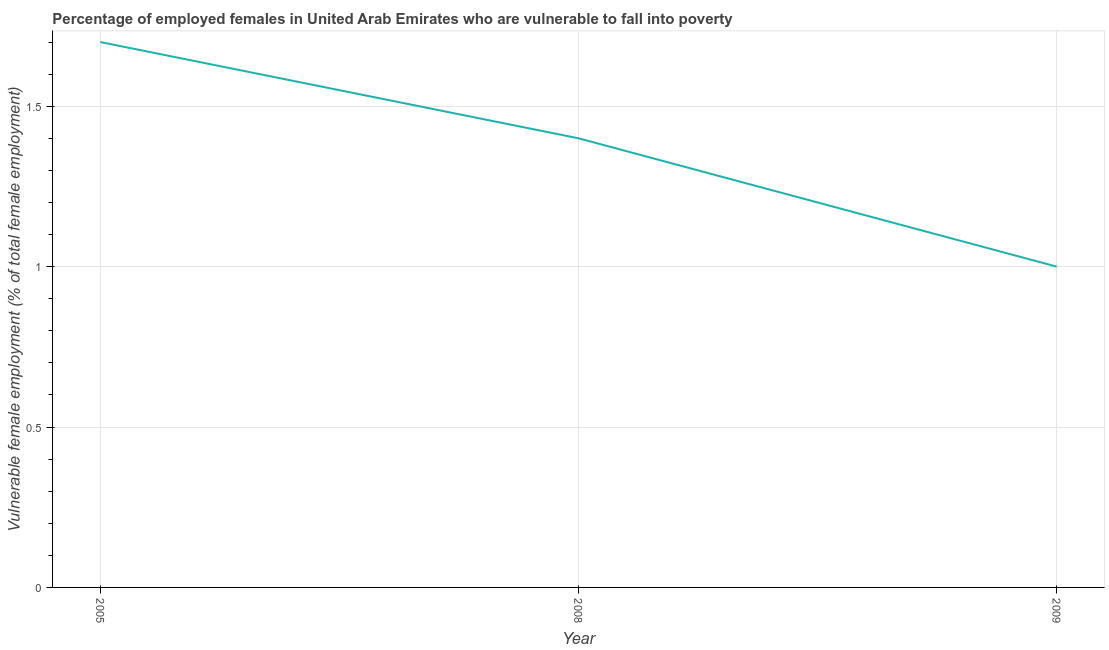What is the percentage of employed females who are vulnerable to fall into poverty in 2009?
Offer a very short reply. 1. Across all years, what is the maximum percentage of employed females who are vulnerable to fall into poverty?
Provide a short and direct response. 1.7. What is the sum of the percentage of employed females who are vulnerable to fall into poverty?
Your response must be concise. 4.1. What is the difference between the percentage of employed females who are vulnerable to fall into poverty in 2008 and 2009?
Offer a terse response. 0.4. What is the average percentage of employed females who are vulnerable to fall into poverty per year?
Your answer should be compact. 1.37. What is the median percentage of employed females who are vulnerable to fall into poverty?
Make the answer very short. 1.4. In how many years, is the percentage of employed females who are vulnerable to fall into poverty greater than 0.8 %?
Keep it short and to the point. 3. Do a majority of the years between 2009 and 2005 (inclusive) have percentage of employed females who are vulnerable to fall into poverty greater than 0.8 %?
Offer a terse response. No. What is the ratio of the percentage of employed females who are vulnerable to fall into poverty in 2008 to that in 2009?
Make the answer very short. 1.4. Is the difference between the percentage of employed females who are vulnerable to fall into poverty in 2005 and 2008 greater than the difference between any two years?
Your response must be concise. No. What is the difference between the highest and the second highest percentage of employed females who are vulnerable to fall into poverty?
Make the answer very short. 0.3. What is the difference between the highest and the lowest percentage of employed females who are vulnerable to fall into poverty?
Provide a succinct answer. 0.7. In how many years, is the percentage of employed females who are vulnerable to fall into poverty greater than the average percentage of employed females who are vulnerable to fall into poverty taken over all years?
Offer a very short reply. 2. Does the percentage of employed females who are vulnerable to fall into poverty monotonically increase over the years?
Offer a terse response. No. How many years are there in the graph?
Offer a terse response. 3. Are the values on the major ticks of Y-axis written in scientific E-notation?
Your answer should be compact. No. Does the graph contain any zero values?
Your answer should be very brief. No. What is the title of the graph?
Provide a succinct answer. Percentage of employed females in United Arab Emirates who are vulnerable to fall into poverty. What is the label or title of the Y-axis?
Offer a very short reply. Vulnerable female employment (% of total female employment). What is the Vulnerable female employment (% of total female employment) of 2005?
Your answer should be compact. 1.7. What is the Vulnerable female employment (% of total female employment) in 2008?
Give a very brief answer. 1.4. What is the Vulnerable female employment (% of total female employment) of 2009?
Keep it short and to the point. 1. What is the difference between the Vulnerable female employment (% of total female employment) in 2005 and 2008?
Make the answer very short. 0.3. What is the difference between the Vulnerable female employment (% of total female employment) in 2008 and 2009?
Give a very brief answer. 0.4. What is the ratio of the Vulnerable female employment (% of total female employment) in 2005 to that in 2008?
Ensure brevity in your answer.  1.21. What is the ratio of the Vulnerable female employment (% of total female employment) in 2005 to that in 2009?
Offer a very short reply. 1.7. 